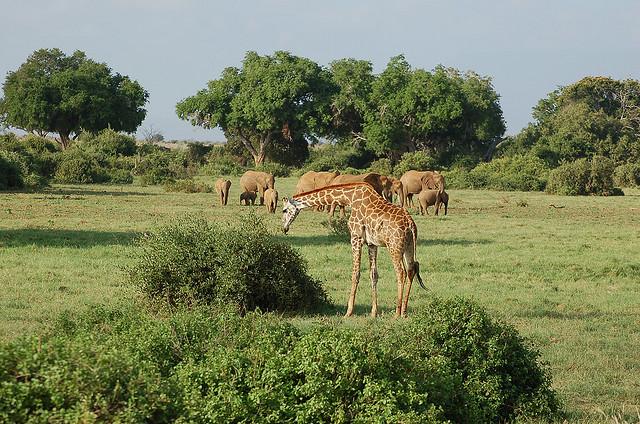Are these giraffe wild?
Answer briefly. Yes. What is the dominant color in this picture?
Quick response, please. Green. What is the giraffe doing?
Keep it brief. Eating. 